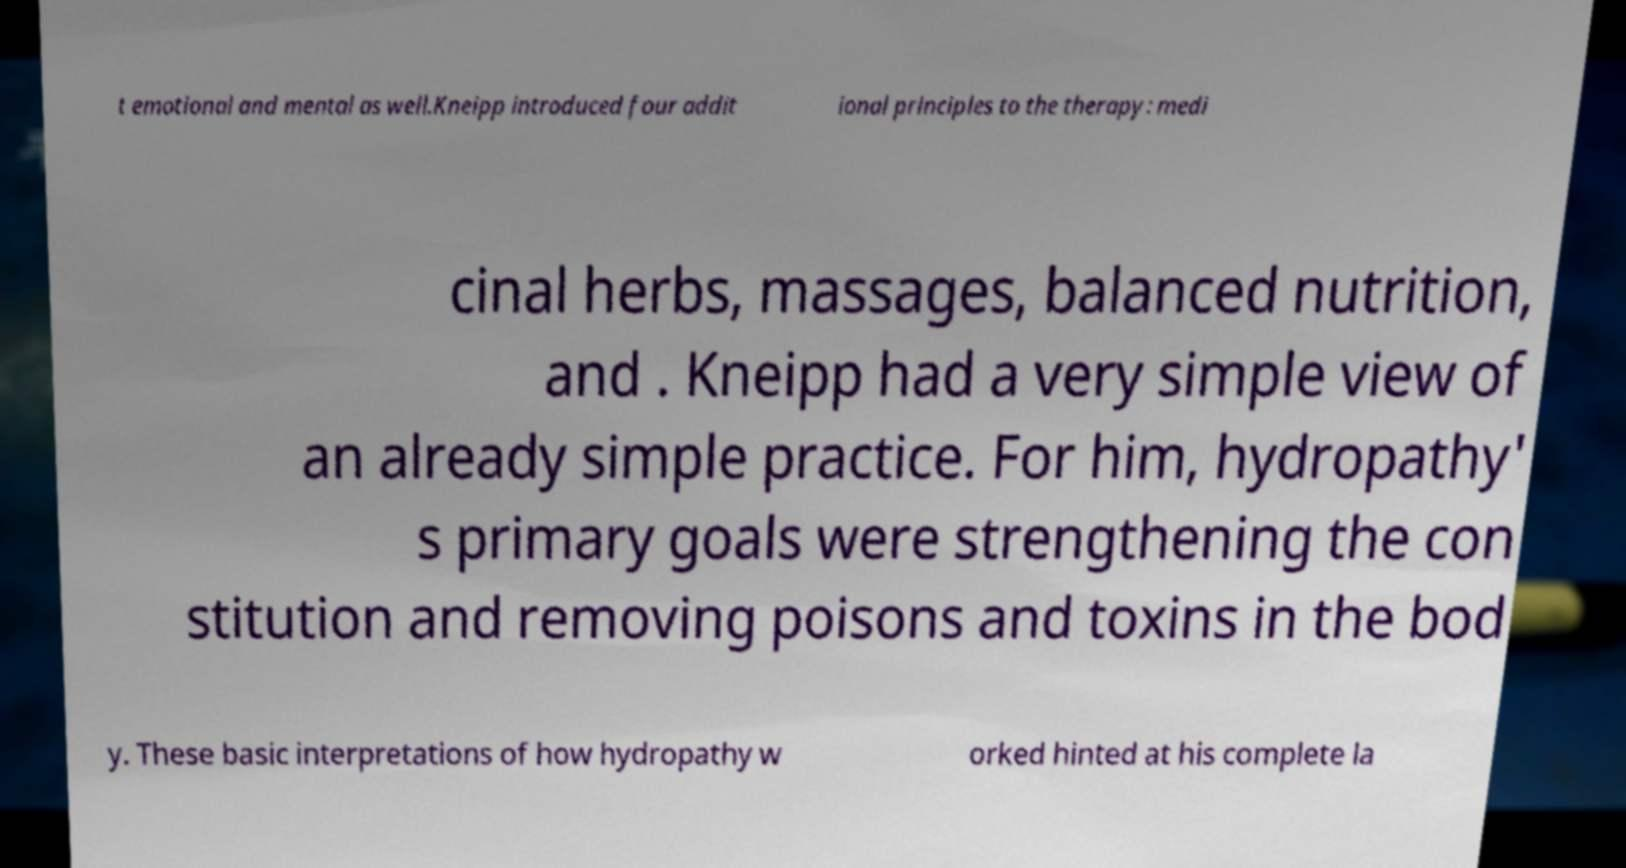What messages or text are displayed in this image? I need them in a readable, typed format. t emotional and mental as well.Kneipp introduced four addit ional principles to the therapy: medi cinal herbs, massages, balanced nutrition, and . Kneipp had a very simple view of an already simple practice. For him, hydropathy' s primary goals were strengthening the con stitution and removing poisons and toxins in the bod y. These basic interpretations of how hydropathy w orked hinted at his complete la 